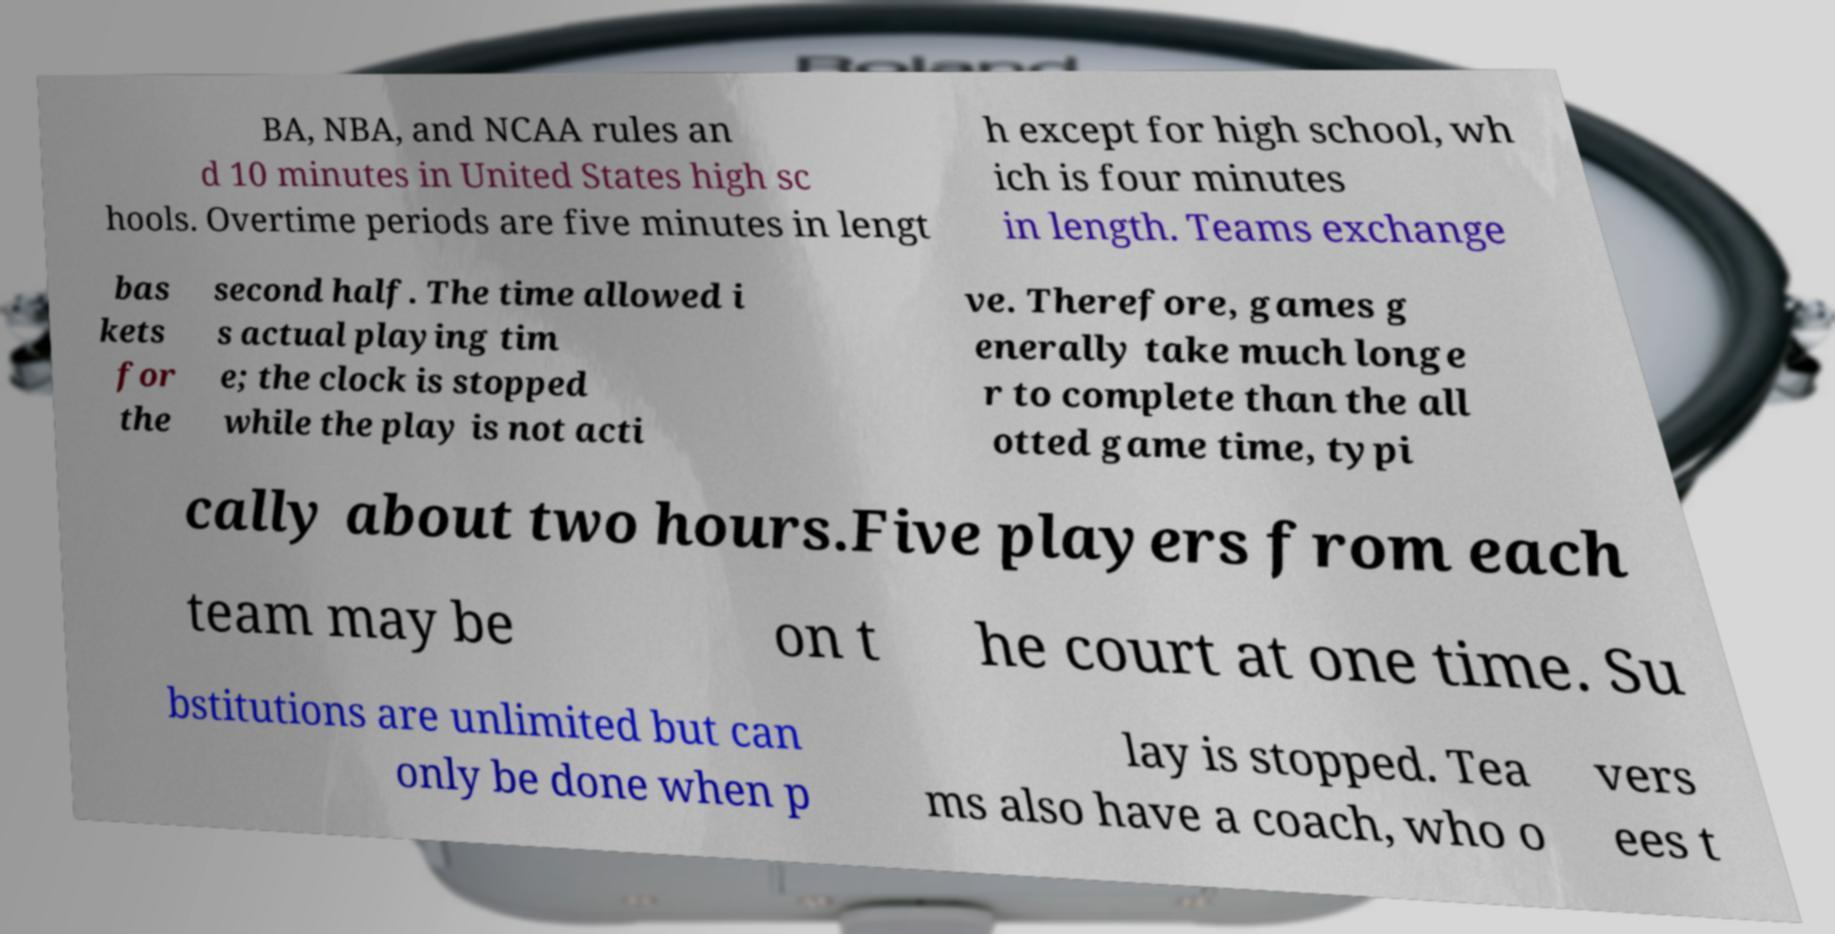What messages or text are displayed in this image? I need them in a readable, typed format. BA, NBA, and NCAA rules an d 10 minutes in United States high sc hools. Overtime periods are five minutes in lengt h except for high school, wh ich is four minutes in length. Teams exchange bas kets for the second half. The time allowed i s actual playing tim e; the clock is stopped while the play is not acti ve. Therefore, games g enerally take much longe r to complete than the all otted game time, typi cally about two hours.Five players from each team may be on t he court at one time. Su bstitutions are unlimited but can only be done when p lay is stopped. Tea ms also have a coach, who o vers ees t 